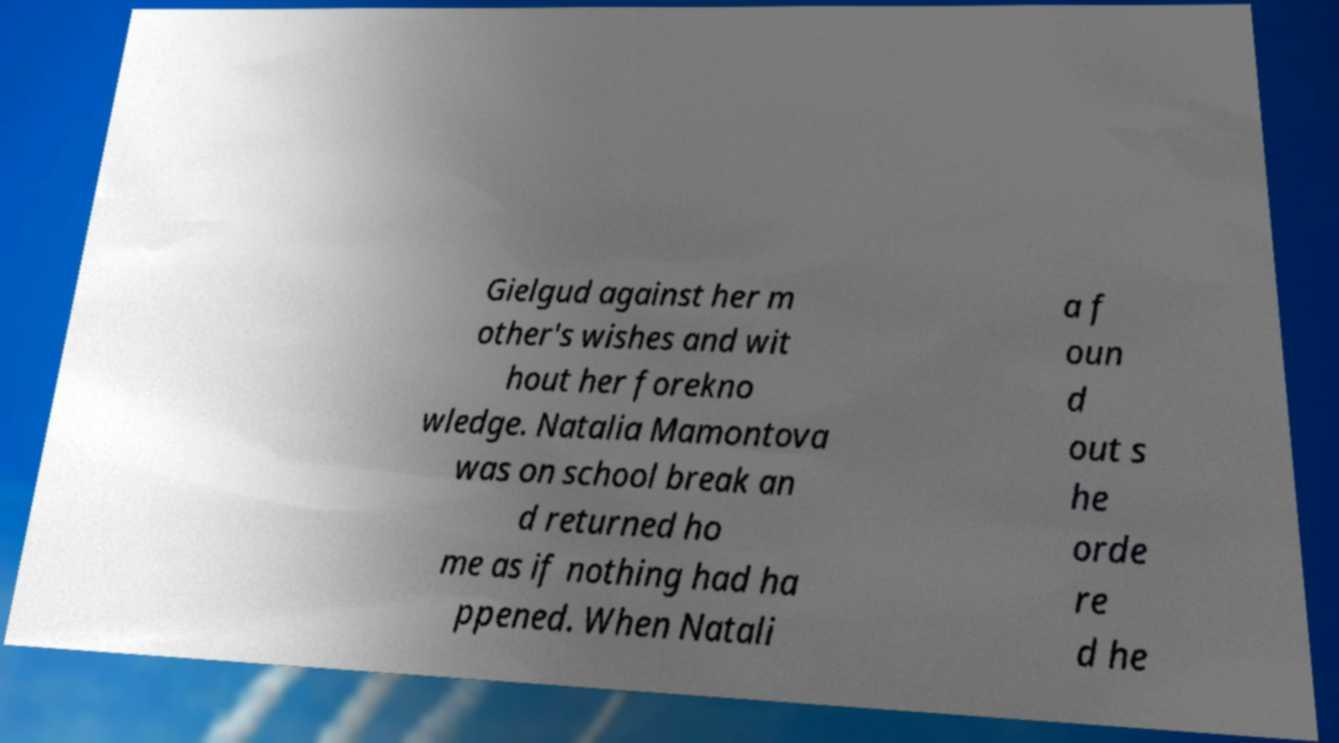There's text embedded in this image that I need extracted. Can you transcribe it verbatim? Gielgud against her m other's wishes and wit hout her forekno wledge. Natalia Mamontova was on school break an d returned ho me as if nothing had ha ppened. When Natali a f oun d out s he orde re d he 